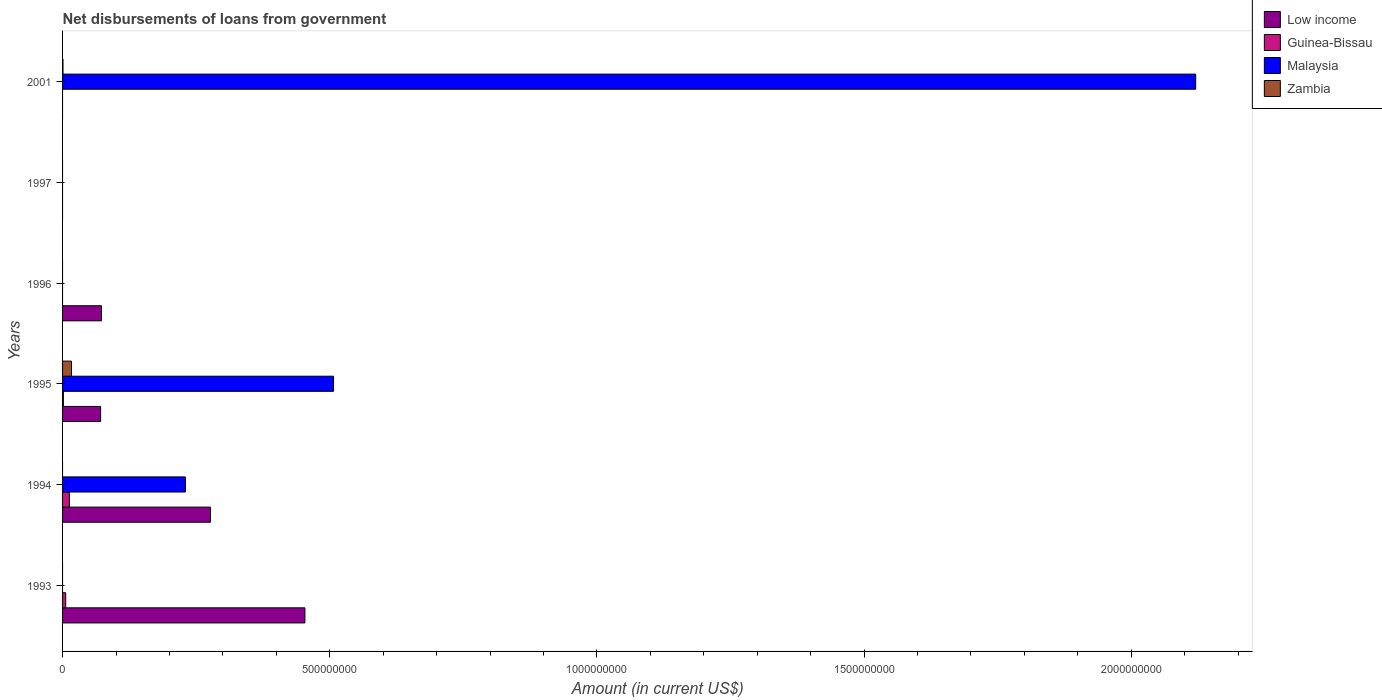Are the number of bars per tick equal to the number of legend labels?
Ensure brevity in your answer.  No. Are the number of bars on each tick of the Y-axis equal?
Your answer should be compact. No. How many bars are there on the 4th tick from the bottom?
Provide a short and direct response. 1. What is the label of the 6th group of bars from the top?
Make the answer very short. 1993. In how many cases, is the number of bars for a given year not equal to the number of legend labels?
Make the answer very short. 5. What is the amount of loan disbursed from government in Low income in 1995?
Your answer should be compact. 7.12e+07. Across all years, what is the maximum amount of loan disbursed from government in Malaysia?
Provide a short and direct response. 2.12e+09. Across all years, what is the minimum amount of loan disbursed from government in Low income?
Your answer should be compact. 0. In which year was the amount of loan disbursed from government in Zambia maximum?
Offer a very short reply. 1995. What is the total amount of loan disbursed from government in Low income in the graph?
Keep it short and to the point. 8.74e+08. What is the difference between the amount of loan disbursed from government in Guinea-Bissau in 1993 and that in 1994?
Keep it short and to the point. -6.84e+06. What is the difference between the amount of loan disbursed from government in Malaysia in 1996 and the amount of loan disbursed from government in Zambia in 1995?
Ensure brevity in your answer.  -1.67e+07. What is the average amount of loan disbursed from government in Zambia per year?
Offer a very short reply. 2.91e+06. In the year 1995, what is the difference between the amount of loan disbursed from government in Malaysia and amount of loan disbursed from government in Guinea-Bissau?
Offer a very short reply. 5.06e+08. What is the ratio of the amount of loan disbursed from government in Malaysia in 1994 to that in 2001?
Ensure brevity in your answer.  0.11. Is the amount of loan disbursed from government in Low income in 1995 less than that in 1996?
Your response must be concise. Yes. What is the difference between the highest and the second highest amount of loan disbursed from government in Malaysia?
Provide a short and direct response. 1.61e+09. What is the difference between the highest and the lowest amount of loan disbursed from government in Guinea-Bissau?
Offer a terse response. 1.27e+07. In how many years, is the amount of loan disbursed from government in Malaysia greater than the average amount of loan disbursed from government in Malaysia taken over all years?
Keep it short and to the point. 2. Is it the case that in every year, the sum of the amount of loan disbursed from government in Low income and amount of loan disbursed from government in Guinea-Bissau is greater than the sum of amount of loan disbursed from government in Zambia and amount of loan disbursed from government in Malaysia?
Make the answer very short. No. How many years are there in the graph?
Offer a very short reply. 6. Does the graph contain any zero values?
Your response must be concise. Yes. How are the legend labels stacked?
Offer a terse response. Vertical. What is the title of the graph?
Keep it short and to the point. Net disbursements of loans from government. Does "Indonesia" appear as one of the legend labels in the graph?
Make the answer very short. No. What is the Amount (in current US$) of Low income in 1993?
Provide a succinct answer. 4.54e+08. What is the Amount (in current US$) in Guinea-Bissau in 1993?
Give a very brief answer. 5.87e+06. What is the Amount (in current US$) of Malaysia in 1993?
Give a very brief answer. 0. What is the Amount (in current US$) in Low income in 1994?
Offer a very short reply. 2.77e+08. What is the Amount (in current US$) in Guinea-Bissau in 1994?
Provide a succinct answer. 1.27e+07. What is the Amount (in current US$) in Malaysia in 1994?
Offer a terse response. 2.30e+08. What is the Amount (in current US$) of Low income in 1995?
Ensure brevity in your answer.  7.12e+07. What is the Amount (in current US$) in Guinea-Bissau in 1995?
Your answer should be compact. 1.52e+06. What is the Amount (in current US$) of Malaysia in 1995?
Give a very brief answer. 5.07e+08. What is the Amount (in current US$) of Zambia in 1995?
Provide a succinct answer. 1.67e+07. What is the Amount (in current US$) in Low income in 1996?
Give a very brief answer. 7.28e+07. What is the Amount (in current US$) in Malaysia in 1996?
Offer a terse response. 0. What is the Amount (in current US$) in Zambia in 1996?
Ensure brevity in your answer.  0. What is the Amount (in current US$) of Malaysia in 1997?
Ensure brevity in your answer.  0. What is the Amount (in current US$) in Guinea-Bissau in 2001?
Offer a terse response. 0. What is the Amount (in current US$) of Malaysia in 2001?
Offer a very short reply. 2.12e+09. What is the Amount (in current US$) of Zambia in 2001?
Give a very brief answer. 7.99e+05. Across all years, what is the maximum Amount (in current US$) of Low income?
Give a very brief answer. 4.54e+08. Across all years, what is the maximum Amount (in current US$) of Guinea-Bissau?
Offer a very short reply. 1.27e+07. Across all years, what is the maximum Amount (in current US$) in Malaysia?
Ensure brevity in your answer.  2.12e+09. Across all years, what is the maximum Amount (in current US$) in Zambia?
Make the answer very short. 1.67e+07. Across all years, what is the minimum Amount (in current US$) of Guinea-Bissau?
Your answer should be very brief. 0. Across all years, what is the minimum Amount (in current US$) of Malaysia?
Offer a terse response. 0. Across all years, what is the minimum Amount (in current US$) of Zambia?
Keep it short and to the point. 0. What is the total Amount (in current US$) of Low income in the graph?
Ensure brevity in your answer.  8.74e+08. What is the total Amount (in current US$) of Guinea-Bissau in the graph?
Provide a short and direct response. 2.01e+07. What is the total Amount (in current US$) in Malaysia in the graph?
Keep it short and to the point. 2.86e+09. What is the total Amount (in current US$) of Zambia in the graph?
Your answer should be compact. 1.75e+07. What is the difference between the Amount (in current US$) of Low income in 1993 and that in 1994?
Provide a short and direct response. 1.77e+08. What is the difference between the Amount (in current US$) in Guinea-Bissau in 1993 and that in 1994?
Offer a very short reply. -6.84e+06. What is the difference between the Amount (in current US$) of Low income in 1993 and that in 1995?
Give a very brief answer. 3.82e+08. What is the difference between the Amount (in current US$) in Guinea-Bissau in 1993 and that in 1995?
Offer a very short reply. 4.35e+06. What is the difference between the Amount (in current US$) in Low income in 1993 and that in 1996?
Keep it short and to the point. 3.81e+08. What is the difference between the Amount (in current US$) in Low income in 1994 and that in 1995?
Ensure brevity in your answer.  2.06e+08. What is the difference between the Amount (in current US$) in Guinea-Bissau in 1994 and that in 1995?
Offer a terse response. 1.12e+07. What is the difference between the Amount (in current US$) in Malaysia in 1994 and that in 1995?
Your response must be concise. -2.77e+08. What is the difference between the Amount (in current US$) in Low income in 1994 and that in 1996?
Offer a terse response. 2.04e+08. What is the difference between the Amount (in current US$) of Malaysia in 1994 and that in 2001?
Offer a terse response. -1.89e+09. What is the difference between the Amount (in current US$) of Low income in 1995 and that in 1996?
Your answer should be very brief. -1.53e+06. What is the difference between the Amount (in current US$) in Malaysia in 1995 and that in 2001?
Offer a very short reply. -1.61e+09. What is the difference between the Amount (in current US$) in Zambia in 1995 and that in 2001?
Your answer should be compact. 1.59e+07. What is the difference between the Amount (in current US$) of Low income in 1993 and the Amount (in current US$) of Guinea-Bissau in 1994?
Offer a terse response. 4.41e+08. What is the difference between the Amount (in current US$) in Low income in 1993 and the Amount (in current US$) in Malaysia in 1994?
Offer a terse response. 2.24e+08. What is the difference between the Amount (in current US$) of Guinea-Bissau in 1993 and the Amount (in current US$) of Malaysia in 1994?
Provide a succinct answer. -2.24e+08. What is the difference between the Amount (in current US$) of Low income in 1993 and the Amount (in current US$) of Guinea-Bissau in 1995?
Make the answer very short. 4.52e+08. What is the difference between the Amount (in current US$) of Low income in 1993 and the Amount (in current US$) of Malaysia in 1995?
Your answer should be very brief. -5.36e+07. What is the difference between the Amount (in current US$) in Low income in 1993 and the Amount (in current US$) in Zambia in 1995?
Give a very brief answer. 4.37e+08. What is the difference between the Amount (in current US$) of Guinea-Bissau in 1993 and the Amount (in current US$) of Malaysia in 1995?
Give a very brief answer. -5.01e+08. What is the difference between the Amount (in current US$) of Guinea-Bissau in 1993 and the Amount (in current US$) of Zambia in 1995?
Offer a terse response. -1.08e+07. What is the difference between the Amount (in current US$) in Low income in 1993 and the Amount (in current US$) in Malaysia in 2001?
Give a very brief answer. -1.67e+09. What is the difference between the Amount (in current US$) of Low income in 1993 and the Amount (in current US$) of Zambia in 2001?
Offer a very short reply. 4.53e+08. What is the difference between the Amount (in current US$) of Guinea-Bissau in 1993 and the Amount (in current US$) of Malaysia in 2001?
Provide a short and direct response. -2.11e+09. What is the difference between the Amount (in current US$) of Guinea-Bissau in 1993 and the Amount (in current US$) of Zambia in 2001?
Keep it short and to the point. 5.07e+06. What is the difference between the Amount (in current US$) in Low income in 1994 and the Amount (in current US$) in Guinea-Bissau in 1995?
Make the answer very short. 2.75e+08. What is the difference between the Amount (in current US$) in Low income in 1994 and the Amount (in current US$) in Malaysia in 1995?
Make the answer very short. -2.30e+08. What is the difference between the Amount (in current US$) in Low income in 1994 and the Amount (in current US$) in Zambia in 1995?
Provide a succinct answer. 2.60e+08. What is the difference between the Amount (in current US$) in Guinea-Bissau in 1994 and the Amount (in current US$) in Malaysia in 1995?
Give a very brief answer. -4.94e+08. What is the difference between the Amount (in current US$) in Guinea-Bissau in 1994 and the Amount (in current US$) in Zambia in 1995?
Your answer should be compact. -3.95e+06. What is the difference between the Amount (in current US$) in Malaysia in 1994 and the Amount (in current US$) in Zambia in 1995?
Offer a very short reply. 2.13e+08. What is the difference between the Amount (in current US$) of Low income in 1994 and the Amount (in current US$) of Malaysia in 2001?
Make the answer very short. -1.84e+09. What is the difference between the Amount (in current US$) of Low income in 1994 and the Amount (in current US$) of Zambia in 2001?
Give a very brief answer. 2.76e+08. What is the difference between the Amount (in current US$) of Guinea-Bissau in 1994 and the Amount (in current US$) of Malaysia in 2001?
Provide a short and direct response. -2.11e+09. What is the difference between the Amount (in current US$) of Guinea-Bissau in 1994 and the Amount (in current US$) of Zambia in 2001?
Make the answer very short. 1.19e+07. What is the difference between the Amount (in current US$) in Malaysia in 1994 and the Amount (in current US$) in Zambia in 2001?
Keep it short and to the point. 2.29e+08. What is the difference between the Amount (in current US$) in Low income in 1995 and the Amount (in current US$) in Malaysia in 2001?
Provide a succinct answer. -2.05e+09. What is the difference between the Amount (in current US$) of Low income in 1995 and the Amount (in current US$) of Zambia in 2001?
Provide a succinct answer. 7.04e+07. What is the difference between the Amount (in current US$) in Guinea-Bissau in 1995 and the Amount (in current US$) in Malaysia in 2001?
Offer a terse response. -2.12e+09. What is the difference between the Amount (in current US$) of Guinea-Bissau in 1995 and the Amount (in current US$) of Zambia in 2001?
Your response must be concise. 7.23e+05. What is the difference between the Amount (in current US$) in Malaysia in 1995 and the Amount (in current US$) in Zambia in 2001?
Your response must be concise. 5.06e+08. What is the difference between the Amount (in current US$) of Low income in 1996 and the Amount (in current US$) of Malaysia in 2001?
Your response must be concise. -2.05e+09. What is the difference between the Amount (in current US$) of Low income in 1996 and the Amount (in current US$) of Zambia in 2001?
Ensure brevity in your answer.  7.20e+07. What is the average Amount (in current US$) in Low income per year?
Keep it short and to the point. 1.46e+08. What is the average Amount (in current US$) of Guinea-Bissau per year?
Provide a succinct answer. 3.35e+06. What is the average Amount (in current US$) of Malaysia per year?
Make the answer very short. 4.76e+08. What is the average Amount (in current US$) of Zambia per year?
Your response must be concise. 2.91e+06. In the year 1993, what is the difference between the Amount (in current US$) of Low income and Amount (in current US$) of Guinea-Bissau?
Your answer should be compact. 4.48e+08. In the year 1994, what is the difference between the Amount (in current US$) in Low income and Amount (in current US$) in Guinea-Bissau?
Your response must be concise. 2.64e+08. In the year 1994, what is the difference between the Amount (in current US$) of Low income and Amount (in current US$) of Malaysia?
Your answer should be compact. 4.69e+07. In the year 1994, what is the difference between the Amount (in current US$) of Guinea-Bissau and Amount (in current US$) of Malaysia?
Your response must be concise. -2.17e+08. In the year 1995, what is the difference between the Amount (in current US$) in Low income and Amount (in current US$) in Guinea-Bissau?
Your answer should be very brief. 6.97e+07. In the year 1995, what is the difference between the Amount (in current US$) of Low income and Amount (in current US$) of Malaysia?
Offer a very short reply. -4.36e+08. In the year 1995, what is the difference between the Amount (in current US$) of Low income and Amount (in current US$) of Zambia?
Keep it short and to the point. 5.46e+07. In the year 1995, what is the difference between the Amount (in current US$) of Guinea-Bissau and Amount (in current US$) of Malaysia?
Your response must be concise. -5.06e+08. In the year 1995, what is the difference between the Amount (in current US$) in Guinea-Bissau and Amount (in current US$) in Zambia?
Ensure brevity in your answer.  -1.51e+07. In the year 1995, what is the difference between the Amount (in current US$) of Malaysia and Amount (in current US$) of Zambia?
Your response must be concise. 4.91e+08. In the year 2001, what is the difference between the Amount (in current US$) of Malaysia and Amount (in current US$) of Zambia?
Your answer should be compact. 2.12e+09. What is the ratio of the Amount (in current US$) in Low income in 1993 to that in 1994?
Your answer should be very brief. 1.64. What is the ratio of the Amount (in current US$) in Guinea-Bissau in 1993 to that in 1994?
Offer a very short reply. 0.46. What is the ratio of the Amount (in current US$) of Low income in 1993 to that in 1995?
Ensure brevity in your answer.  6.37. What is the ratio of the Amount (in current US$) of Guinea-Bissau in 1993 to that in 1995?
Your answer should be compact. 3.86. What is the ratio of the Amount (in current US$) in Low income in 1993 to that in 1996?
Your answer should be compact. 6.23. What is the ratio of the Amount (in current US$) in Low income in 1994 to that in 1995?
Your answer should be compact. 3.88. What is the ratio of the Amount (in current US$) in Guinea-Bissau in 1994 to that in 1995?
Your response must be concise. 8.35. What is the ratio of the Amount (in current US$) of Malaysia in 1994 to that in 1995?
Provide a short and direct response. 0.45. What is the ratio of the Amount (in current US$) in Low income in 1994 to that in 1996?
Provide a short and direct response. 3.8. What is the ratio of the Amount (in current US$) of Malaysia in 1994 to that in 2001?
Offer a terse response. 0.11. What is the ratio of the Amount (in current US$) of Low income in 1995 to that in 1996?
Provide a succinct answer. 0.98. What is the ratio of the Amount (in current US$) in Malaysia in 1995 to that in 2001?
Offer a very short reply. 0.24. What is the ratio of the Amount (in current US$) in Zambia in 1995 to that in 2001?
Offer a terse response. 20.85. What is the difference between the highest and the second highest Amount (in current US$) of Low income?
Offer a very short reply. 1.77e+08. What is the difference between the highest and the second highest Amount (in current US$) in Guinea-Bissau?
Offer a terse response. 6.84e+06. What is the difference between the highest and the second highest Amount (in current US$) of Malaysia?
Your answer should be compact. 1.61e+09. What is the difference between the highest and the lowest Amount (in current US$) of Low income?
Offer a terse response. 4.54e+08. What is the difference between the highest and the lowest Amount (in current US$) in Guinea-Bissau?
Make the answer very short. 1.27e+07. What is the difference between the highest and the lowest Amount (in current US$) in Malaysia?
Your answer should be compact. 2.12e+09. What is the difference between the highest and the lowest Amount (in current US$) in Zambia?
Keep it short and to the point. 1.67e+07. 